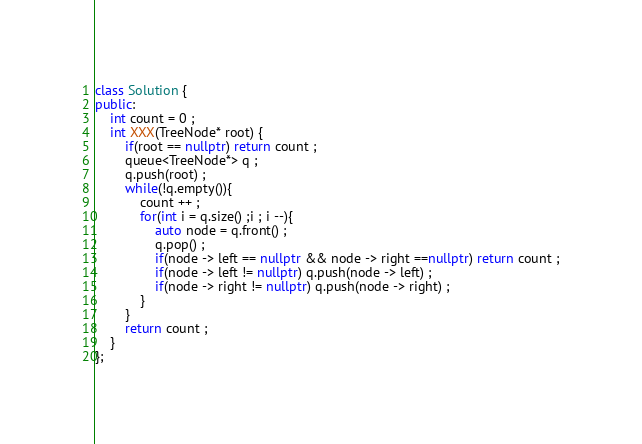<code> <loc_0><loc_0><loc_500><loc_500><_C++_>class Solution {
public:
    int count = 0 ;
    int XXX(TreeNode* root) {
        if(root == nullptr) return count ;
        queue<TreeNode*> q ;
        q.push(root) ;
        while(!q.empty()){
            count ++ ; 
            for(int i = q.size() ;i ; i --){
                auto node = q.front() ;
                q.pop() ;
                if(node -> left == nullptr && node -> right ==nullptr) return count ;
                if(node -> left != nullptr) q.push(node -> left) ;
                if(node -> right != nullptr) q.push(node -> right) ;
            }
        }
        return count ;
    }
};

</code> 